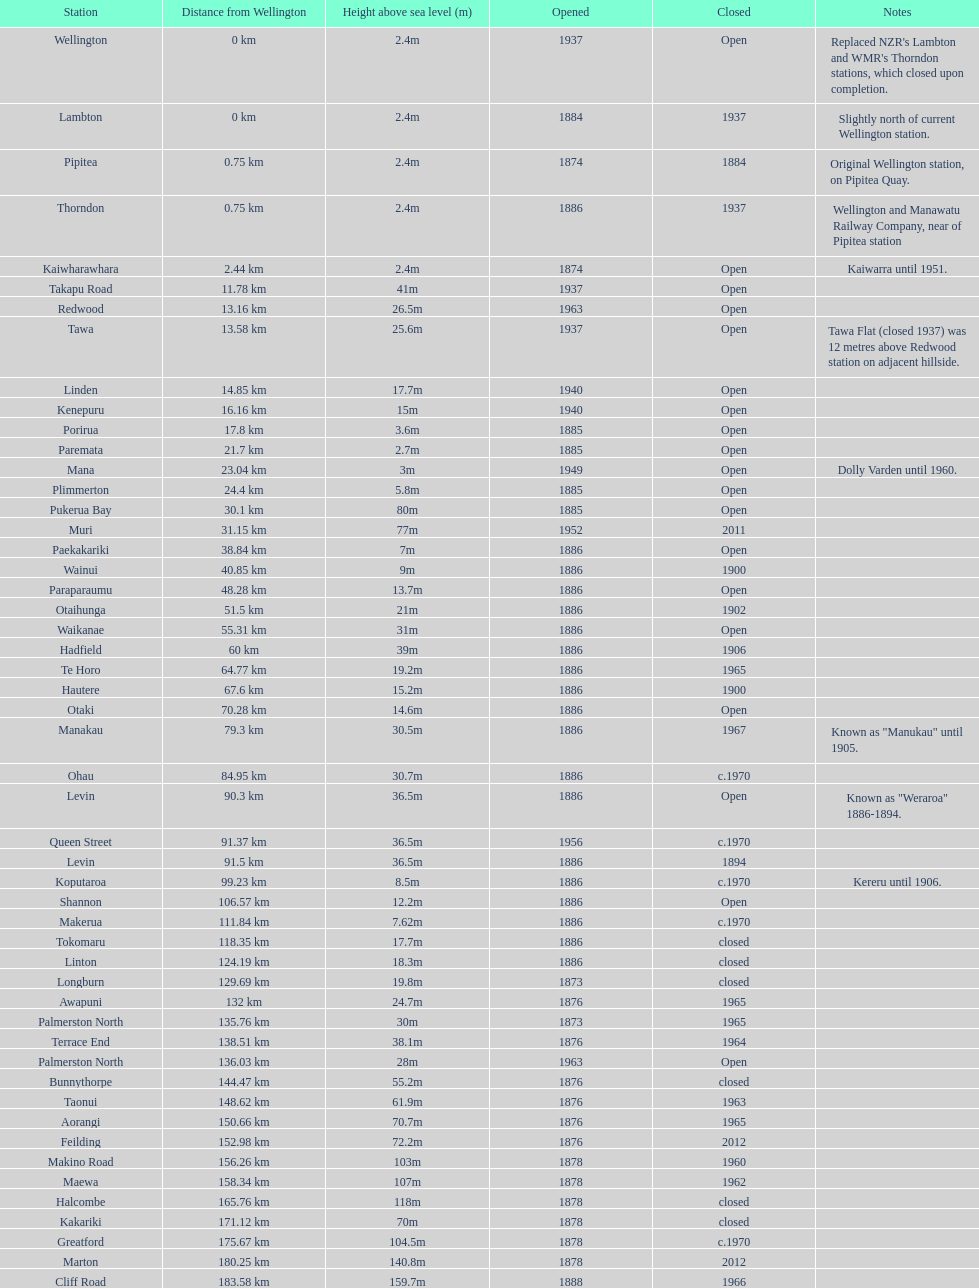What is the altitude difference between takapu road station and wellington station? 38.6m. 